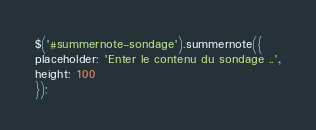Convert code to text. <code><loc_0><loc_0><loc_500><loc_500><_JavaScript_>$('#summernote-sondage').summernote({
placeholder: 'Enter le contenu du sondage ..',
height: 100
});</code> 